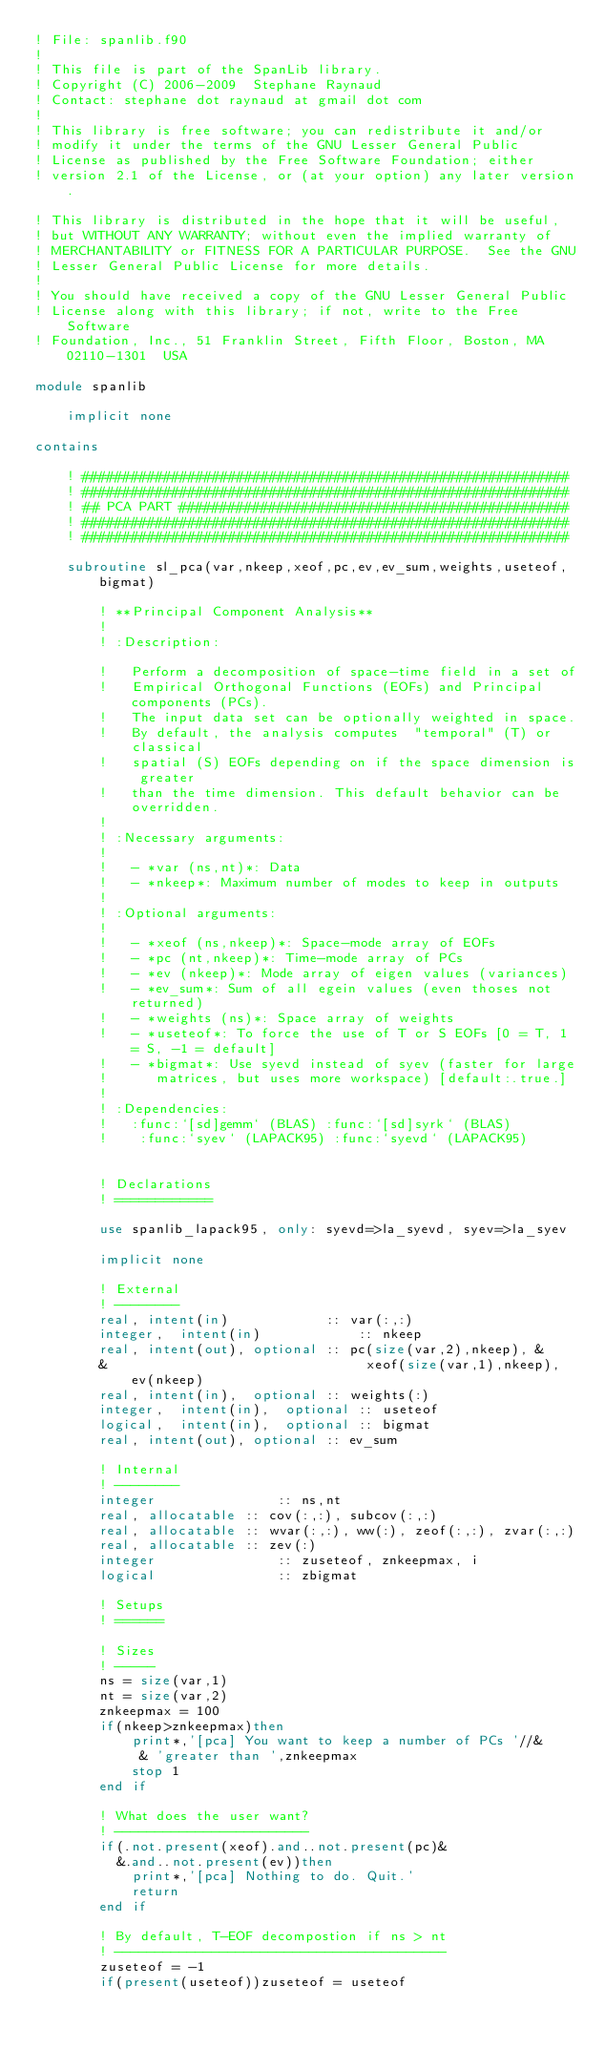Convert code to text. <code><loc_0><loc_0><loc_500><loc_500><_FORTRAN_>! File: spanlib.f90
!
! This file is part of the SpanLib library.
! Copyright (C) 2006-2009  Stephane Raynaud
! Contact: stephane dot raynaud at gmail dot com
!
! This library is free software; you can redistribute it and/or
! modify it under the terms of the GNU Lesser General Public
! License as published by the Free Software Foundation; either
! version 2.1 of the License, or (at your option) any later version.

! This library is distributed in the hope that it will be useful,
! but WITHOUT ANY WARRANTY; without even the implied warranty of
! MERCHANTABILITY or FITNESS FOR A PARTICULAR PURPOSE.  See the GNU
! Lesser General Public License for more details.
!
! You should have received a copy of the GNU Lesser General Public
! License along with this library; if not, write to the Free Software
! Foundation, Inc., 51 Franklin Street, Fifth Floor, Boston, MA  02110-1301  USA

module spanlib

	implicit none

contains

	! ############################################################
	! ############################################################
	! ## PCA PART ################################################
	! ############################################################
	! ############################################################

	subroutine sl_pca(var,nkeep,xeof,pc,ev,ev_sum,weights,useteof, bigmat)

		! **Principal Component Analysis**
		!
		! :Description:
		
		!	Perform a decomposition of space-time field in a set of
		!	Empirical Orthogonal Functions (EOFs) and Principal components (PCs).
		!	The input data set can be optionally weighted in space.
		!	By default, the analysis computes  "temporal" (T) or classical
		!	spatial (S) EOFs depending on if the space dimension is greater
		!	than the time dimension. This default behavior can be overridden.
		!
		! :Necessary arguments:
		!
		!	- *var (ns,nt)*: Data
		!	- *nkeep*: Maximum number of modes to keep in outputs
		!
		! :Optional arguments:
		!
		!	- *xeof (ns,nkeep)*: Space-mode array of EOFs
		!	- *pc (nt,nkeep)*: Time-mode array of PCs
		!	- *ev (nkeep)*: Mode array of eigen values (variances)
		!	- *ev_sum*: Sum of all egein values (even thoses not returned)
		!	- *weights (ns)*: Space array of weights
		!	- *useteof*: To force the use of T or S EOFs [0 = T, 1 = S, -1 = default]
		!	- *bigmat*: Use syevd instead of syev (faster for large 
		!      matrices, but uses more workspace) [default:.true.]
		!
		! :Dependencies:
		!	:func:`[sd]gemm` (BLAS) :func:`[sd]syrk` (BLAS) 
		!    :func:`syev` (LAPACK95) :func:`syevd` (LAPACK95)
	
	
		! Declarations
		! ============
	
		use spanlib_lapack95, only: syevd=>la_syevd, syev=>la_syev
	
		implicit none
	
		! External
		! --------
		real, intent(in)            :: var(:,:)
		integer,  intent(in)	        :: nkeep
		real, intent(out), optional :: pc(size(var,2),nkeep), &
		&                                xeof(size(var,1),nkeep), ev(nkeep)
		real, intent(in),  optional :: weights(:)
		integer,  intent(in),  optional :: useteof
		logical,  intent(in),  optional :: bigmat
		real, intent(out), optional :: ev_sum
	
		! Internal
		! --------
		integer               :: ns,nt
		real, allocatable :: cov(:,:), subcov(:,:)
		real, allocatable :: wvar(:,:), ww(:), zeof(:,:), zvar(:,:)
		real, allocatable :: zev(:)
		integer               :: zuseteof, znkeepmax, i
		logical               :: zbigmat
	
		! Setups
		! ======
	
		! Sizes
		! -----
		ns = size(var,1)
		nt = size(var,2)
		znkeepmax = 100
		if(nkeep>znkeepmax)then
			print*,'[pca] You want to keep a number of PCs '//&
			 & 'greater than ',znkeepmax
			stop 1
		end if
	
		! What does the user want?
		! ------------------------
		if(.not.present(xeof).and..not.present(pc)&
		  &.and..not.present(ev))then
			print*,'[pca] Nothing to do. Quit.'
			return
		end if
	
		! By default, T-EOF decompostion if ns > nt
		! -----------------------------------------
		zuseteof = -1
		if(present(useteof))zuseteof = useteof</code> 